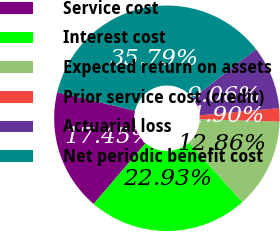<chart> <loc_0><loc_0><loc_500><loc_500><pie_chart><fcel>Service cost<fcel>Interest cost<fcel>Expected return on assets<fcel>Prior service cost (credit)<fcel>Actuarial loss<fcel>Net periodic benefit cost<nl><fcel>17.45%<fcel>22.93%<fcel>12.86%<fcel>1.9%<fcel>9.06%<fcel>35.79%<nl></chart> 